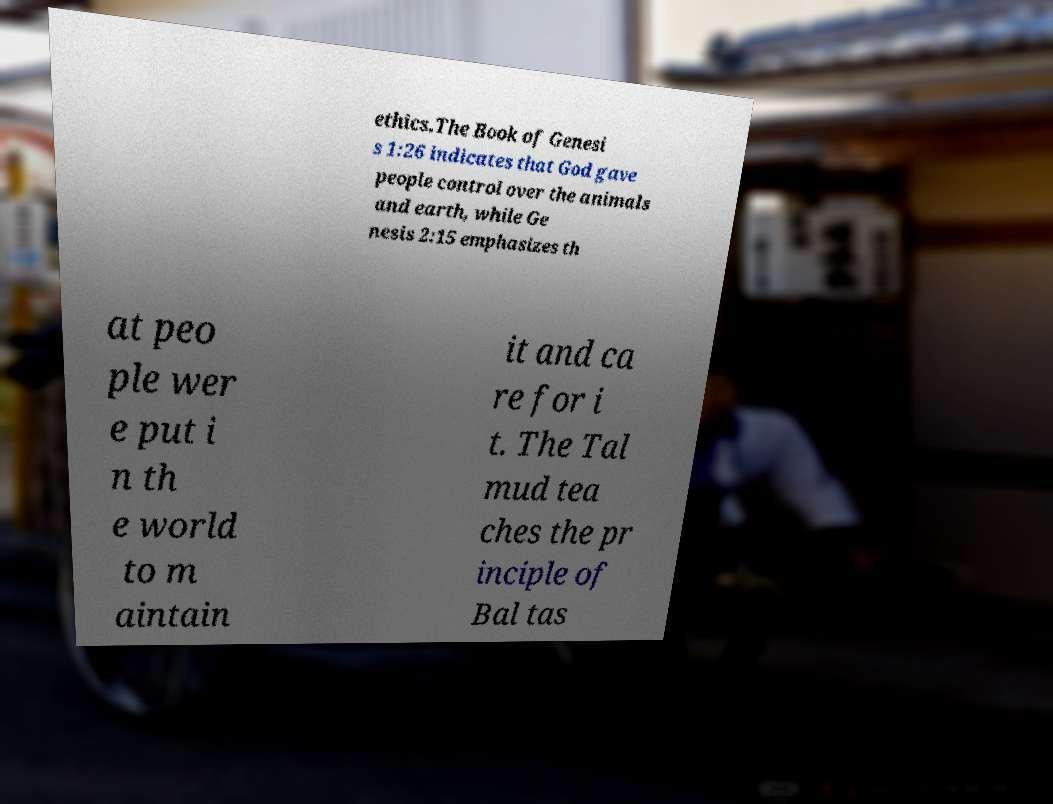For documentation purposes, I need the text within this image transcribed. Could you provide that? ethics.The Book of Genesi s 1:26 indicates that God gave people control over the animals and earth, while Ge nesis 2:15 emphasizes th at peo ple wer e put i n th e world to m aintain it and ca re for i t. The Tal mud tea ches the pr inciple of Bal tas 